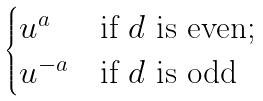Convert formula to latex. <formula><loc_0><loc_0><loc_500><loc_500>\begin{cases} u ^ { a } & \text {if $d$ is even;} \\ u ^ { - a } & \text {if $d$ is odd} \end{cases}</formula> 